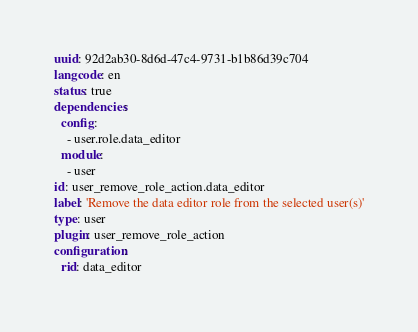<code> <loc_0><loc_0><loc_500><loc_500><_YAML_>uuid: 92d2ab30-8d6d-47c4-9731-b1b86d39c704
langcode: en
status: true
dependencies:
  config:
    - user.role.data_editor
  module:
    - user
id: user_remove_role_action.data_editor
label: 'Remove the data editor role from the selected user(s)'
type: user
plugin: user_remove_role_action
configuration:
  rid: data_editor
</code> 